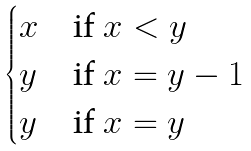<formula> <loc_0><loc_0><loc_500><loc_500>\begin{cases} x & \text {if } x < y \\ y & \text {if } x = y - 1 \\ y & \text {if } x = y \end{cases}</formula> 